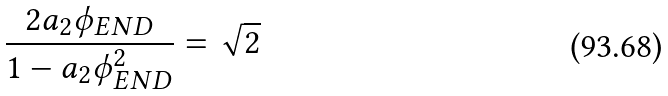Convert formula to latex. <formula><loc_0><loc_0><loc_500><loc_500>\frac { 2 a _ { 2 } \phi _ { E N D } } { 1 - a _ { 2 } \phi _ { E N D } ^ { 2 } } = \sqrt { 2 }</formula> 